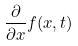Convert formula to latex. <formula><loc_0><loc_0><loc_500><loc_500>\frac { \partial } { \partial x } f ( x , t )</formula> 